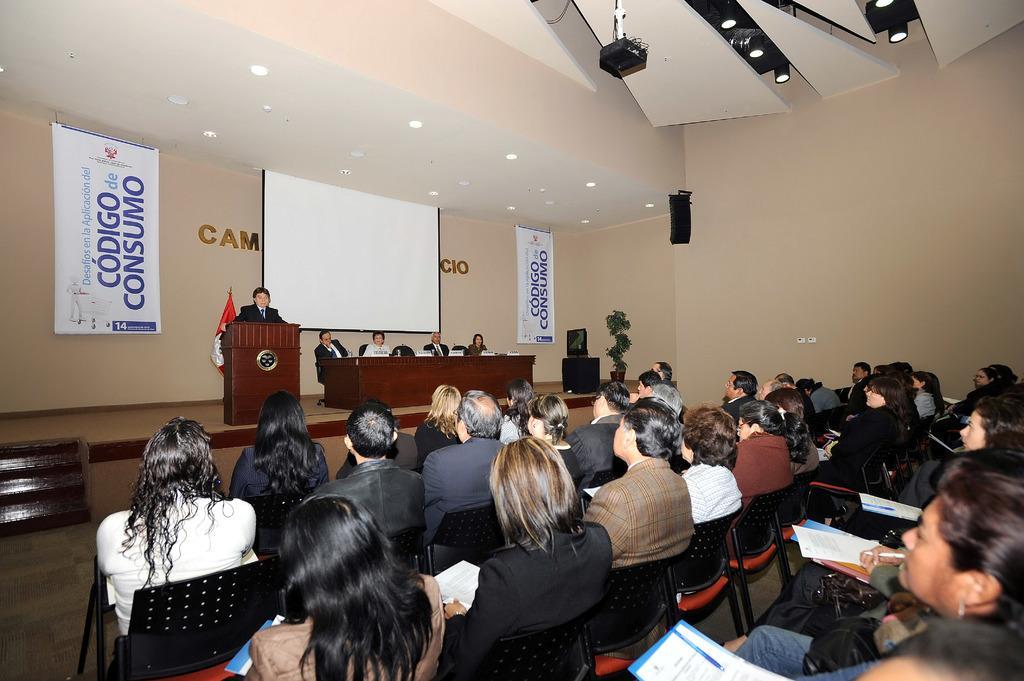Describe this image in one or two sentences. This image consists of many persons sitting in the chairs. At the bottom, there is a floor. In the front, there is a podium and a table. In the background, we can see a projector screen and banners on the wall. At the bottom, there is a floor. At the top, there are lights. 